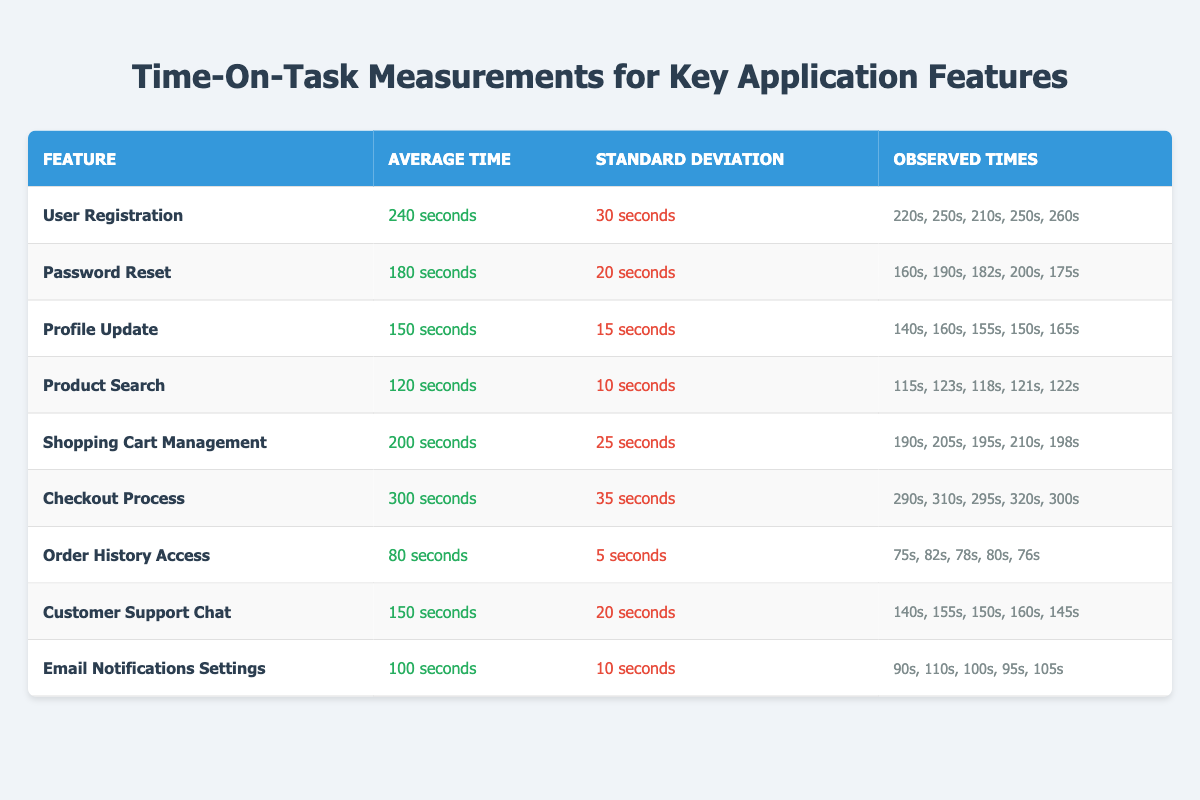What is the average time for the Password Reset feature? The average time for the Password Reset feature is stated in the table as 180 seconds.
Answer: 180 seconds Which feature has the highest average time on task? The Checkout Process has the highest average time listed at 300 seconds, which is greater than all other features noted in the table.
Answer: Checkout Process What is the standard deviation of the time for Profile Update? The standard deviation for the Profile Update feature is indicated in the table as 15 seconds.
Answer: 15 seconds How many features have an average time of less than 150 seconds? By reviewing the table, three features (Product Search, Order History Access, and Email Notifications Settings) are confirmed to have average times less than 150 seconds.
Answer: 3 features What is the total observed time for all instances of the User Registration feature? The observed times for User Registration are 220, 250, 210, 250, and 260 seconds. Summing these gives (220 + 250 + 210 + 250 + 260) = 1190 seconds.
Answer: 1190 seconds Is the average time for Customer Support Chat more than 160 seconds? The average time for Customer Support Chat is 150 seconds, which is not more than 160 seconds, so the answer is false.
Answer: No What is the difference in average time between the Checkout Process and the Product Search? The average time for the Checkout Process is 300 seconds and for Product Search is 120 seconds. The difference is (300 - 120) = 180 seconds.
Answer: 180 seconds Which two features have the lowest standard deviation in their completion times? The features with the lowest standard deviations are Order History Access (5 seconds) and Product Search (10 seconds). Both values are the smallest compared to all other features.
Answer: Order History Access and Product Search What is the average of the observed times for the Email Notifications Settings? The observed times are 90, 110, 100, 95, and 105 seconds. Summing these gives 500 seconds, and dividing by 5 gives an average of (500/5) = 100 seconds.
Answer: 100 seconds Is there any feature with an average time that is below 100 seconds? The table shows that the average time for all features listed is greater than or equal to 80 seconds (the lowest value), making the answer false.
Answer: No 